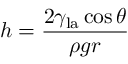Convert formula to latex. <formula><loc_0><loc_0><loc_500><loc_500>h = { \frac { 2 \gamma _ { l a } \cos \theta } { \rho g r } }</formula> 